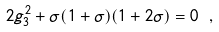Convert formula to latex. <formula><loc_0><loc_0><loc_500><loc_500>2 g _ { 3 } ^ { 2 } + \sigma ( 1 + \sigma ) ( 1 + 2 \sigma ) = 0 \ ,</formula> 